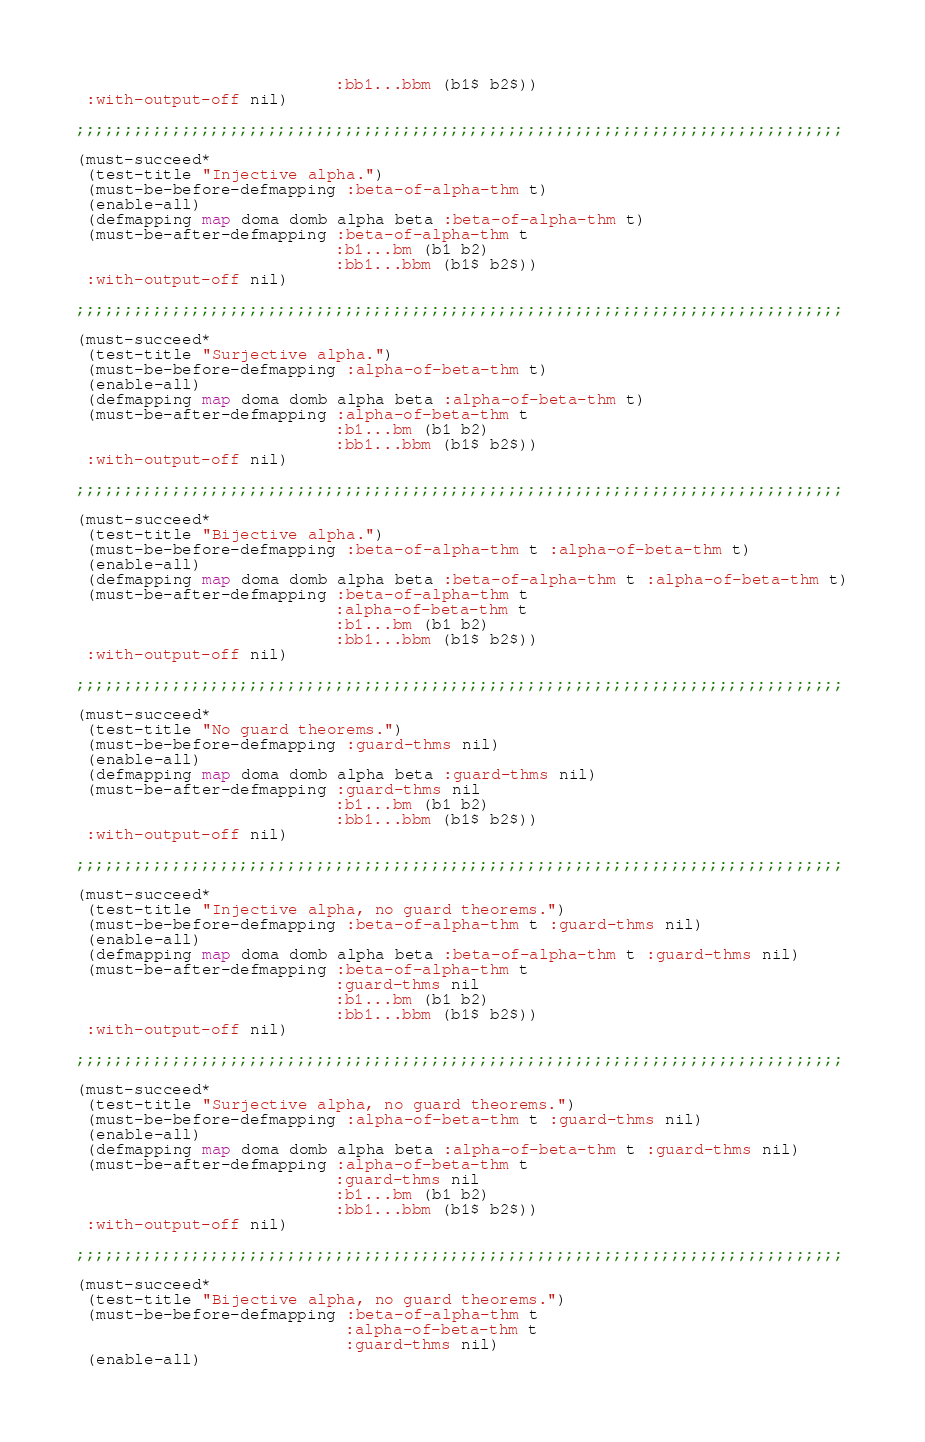<code> <loc_0><loc_0><loc_500><loc_500><_Lisp_>                           :bb1...bbm (b1$ b2$))
 :with-output-off nil)

;;;;;;;;;;;;;;;;;;;;;;;;;;;;;;;;;;;;;;;;;;;;;;;;;;;;;;;;;;;;;;;;;;;;;;;;;;;;;;;;

(must-succeed*
 (test-title "Injective alpha.")
 (must-be-before-defmapping :beta-of-alpha-thm t)
 (enable-all)
 (defmapping map doma domb alpha beta :beta-of-alpha-thm t)
 (must-be-after-defmapping :beta-of-alpha-thm t
                           :b1...bm (b1 b2)
                           :bb1...bbm (b1$ b2$))
 :with-output-off nil)

;;;;;;;;;;;;;;;;;;;;;;;;;;;;;;;;;;;;;;;;;;;;;;;;;;;;;;;;;;;;;;;;;;;;;;;;;;;;;;;;

(must-succeed*
 (test-title "Surjective alpha.")
 (must-be-before-defmapping :alpha-of-beta-thm t)
 (enable-all)
 (defmapping map doma domb alpha beta :alpha-of-beta-thm t)
 (must-be-after-defmapping :alpha-of-beta-thm t
                           :b1...bm (b1 b2)
                           :bb1...bbm (b1$ b2$))
 :with-output-off nil)

;;;;;;;;;;;;;;;;;;;;;;;;;;;;;;;;;;;;;;;;;;;;;;;;;;;;;;;;;;;;;;;;;;;;;;;;;;;;;;;;

(must-succeed*
 (test-title "Bijective alpha.")
 (must-be-before-defmapping :beta-of-alpha-thm t :alpha-of-beta-thm t)
 (enable-all)
 (defmapping map doma domb alpha beta :beta-of-alpha-thm t :alpha-of-beta-thm t)
 (must-be-after-defmapping :beta-of-alpha-thm t
                           :alpha-of-beta-thm t
                           :b1...bm (b1 b2)
                           :bb1...bbm (b1$ b2$))
 :with-output-off nil)

;;;;;;;;;;;;;;;;;;;;;;;;;;;;;;;;;;;;;;;;;;;;;;;;;;;;;;;;;;;;;;;;;;;;;;;;;;;;;;;;

(must-succeed*
 (test-title "No guard theorems.")
 (must-be-before-defmapping :guard-thms nil)
 (enable-all)
 (defmapping map doma domb alpha beta :guard-thms nil)
 (must-be-after-defmapping :guard-thms nil
                           :b1...bm (b1 b2)
                           :bb1...bbm (b1$ b2$))
 :with-output-off nil)

;;;;;;;;;;;;;;;;;;;;;;;;;;;;;;;;;;;;;;;;;;;;;;;;;;;;;;;;;;;;;;;;;;;;;;;;;;;;;;;;

(must-succeed*
 (test-title "Injective alpha, no guard theorems.")
 (must-be-before-defmapping :beta-of-alpha-thm t :guard-thms nil)
 (enable-all)
 (defmapping map doma domb alpha beta :beta-of-alpha-thm t :guard-thms nil)
 (must-be-after-defmapping :beta-of-alpha-thm t
                           :guard-thms nil
                           :b1...bm (b1 b2)
                           :bb1...bbm (b1$ b2$))
 :with-output-off nil)

;;;;;;;;;;;;;;;;;;;;;;;;;;;;;;;;;;;;;;;;;;;;;;;;;;;;;;;;;;;;;;;;;;;;;;;;;;;;;;;;

(must-succeed*
 (test-title "Surjective alpha, no guard theorems.")
 (must-be-before-defmapping :alpha-of-beta-thm t :guard-thms nil)
 (enable-all)
 (defmapping map doma domb alpha beta :alpha-of-beta-thm t :guard-thms nil)
 (must-be-after-defmapping :alpha-of-beta-thm t
                           :guard-thms nil
                           :b1...bm (b1 b2)
                           :bb1...bbm (b1$ b2$))
 :with-output-off nil)

;;;;;;;;;;;;;;;;;;;;;;;;;;;;;;;;;;;;;;;;;;;;;;;;;;;;;;;;;;;;;;;;;;;;;;;;;;;;;;;;

(must-succeed*
 (test-title "Bijective alpha, no guard theorems.")
 (must-be-before-defmapping :beta-of-alpha-thm t
                            :alpha-of-beta-thm t
                            :guard-thms nil)
 (enable-all)</code> 